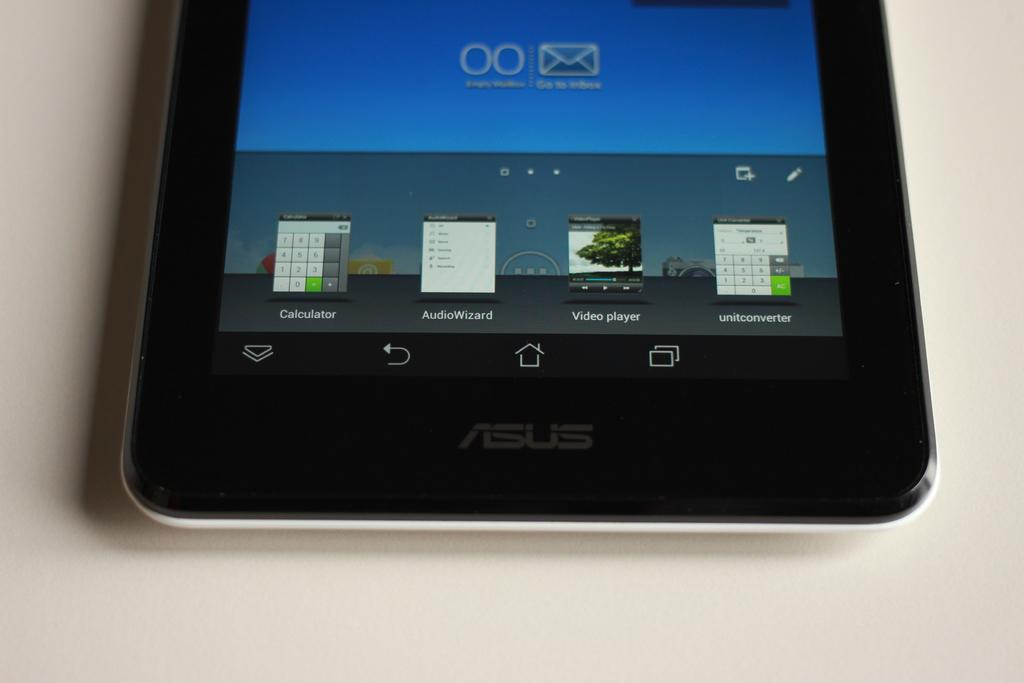What is the main object in the image? There is a mobile in the image. Where is the mobile located? The mobile is on a surface. What can be seen on the mobile display? There are icons visible on the mobile display. What type of flower is growing next to the mobile in the image? There is no flower present in the image; it only features a mobile on a surface with icons visible on the display. 